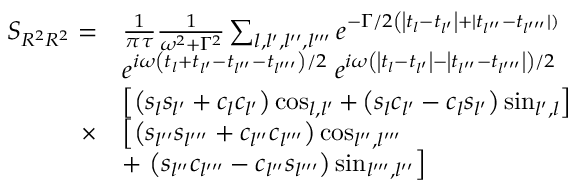Convert formula to latex. <formula><loc_0><loc_0><loc_500><loc_500>\begin{array} { r l } { S _ { R ^ { 2 } R ^ { 2 } } = } & { \frac { 1 } { \pi \tau } \frac { 1 } { \omega ^ { 2 } + \Gamma ^ { 2 } } \sum _ { l , l ^ { \prime } , l ^ { \prime \prime } , l ^ { \prime \prime \prime } } e ^ { - \Gamma / 2 \left ( \left | t _ { l } - t _ { l ^ { \prime } } \right | + | t _ { l ^ { \prime \prime } } - t _ { l ^ { \prime \prime \prime } } | ) } } \\ & { e ^ { i \omega \left ( t _ { l } + t _ { l ^ { \prime } } - t _ { l ^ { \prime \prime } } - t _ { l ^ { \prime \prime \prime } } \right ) / 2 } \, e ^ { i \omega \left ( \left | t _ { l } - t _ { l ^ { \prime } } \right | - \left | t _ { l ^ { \prime \prime } } - t _ { l ^ { \prime \prime \prime } } \right | \right ) / 2 } } \\ & { \left [ \left ( s _ { l } s _ { l ^ { \prime } } + c _ { l } c _ { l ^ { \prime } } \right ) \cos _ { l , l ^ { \prime } } + \left ( s _ { l } c _ { l ^ { \prime } } - c _ { l } s _ { l ^ { \prime } } \right ) \sin _ { l ^ { \prime } , l } \right ] } \\ { \times } & { \left [ \left ( s _ { l ^ { \prime \prime } } s _ { l ^ { \prime \prime \prime } } + c _ { l ^ { \prime \prime } } c _ { l ^ { \prime \prime \prime } } \right ) \cos _ { l ^ { \prime \prime } , l ^ { \prime \prime \prime } } } \\ & { + \left ( s _ { l ^ { \prime \prime } } c _ { l ^ { \prime \prime \prime } } - c _ { l ^ { \prime \prime } } s _ { l ^ { \prime \prime \prime } } \right ) \sin _ { l ^ { \prime \prime \prime } , l ^ { \prime \prime } } \right ] } \end{array}</formula> 